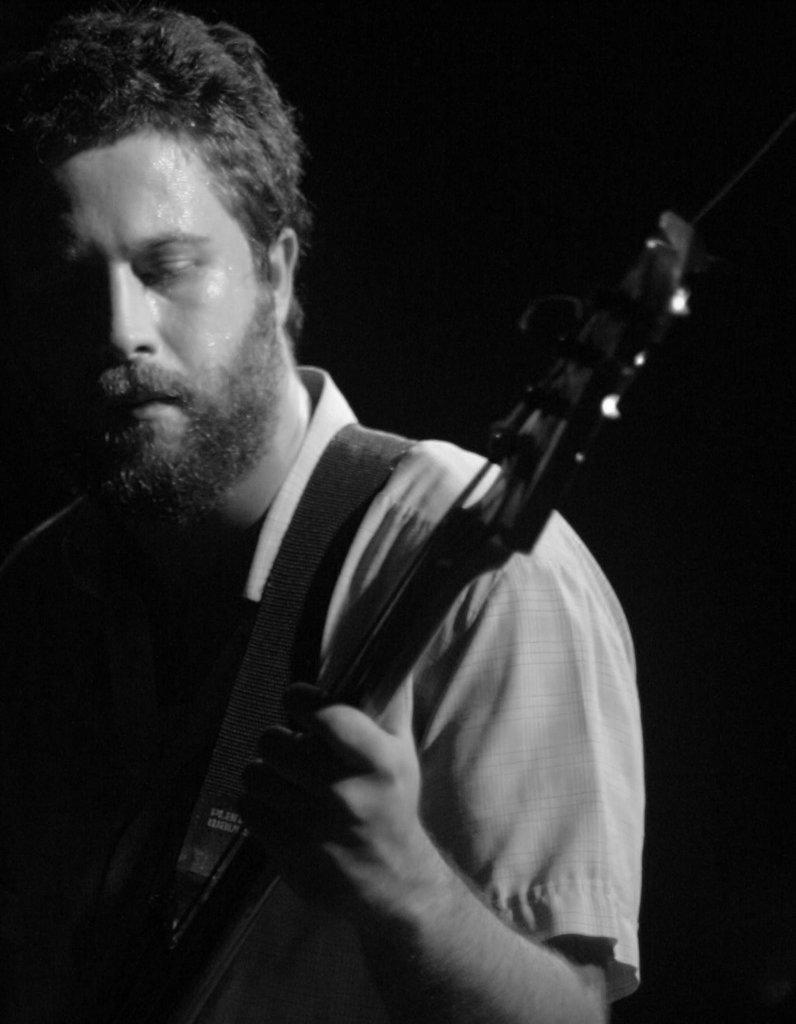What is the man in the image holding? The man is holding a guitar. How is the guitar attached to the man? The man has a guitar strap. What can be observed about the background of the image? The background of the image is dark. What type of bike does the man's daughter ride in the image? There is no bike or daughter present in the image; it features a man holding a guitar. 